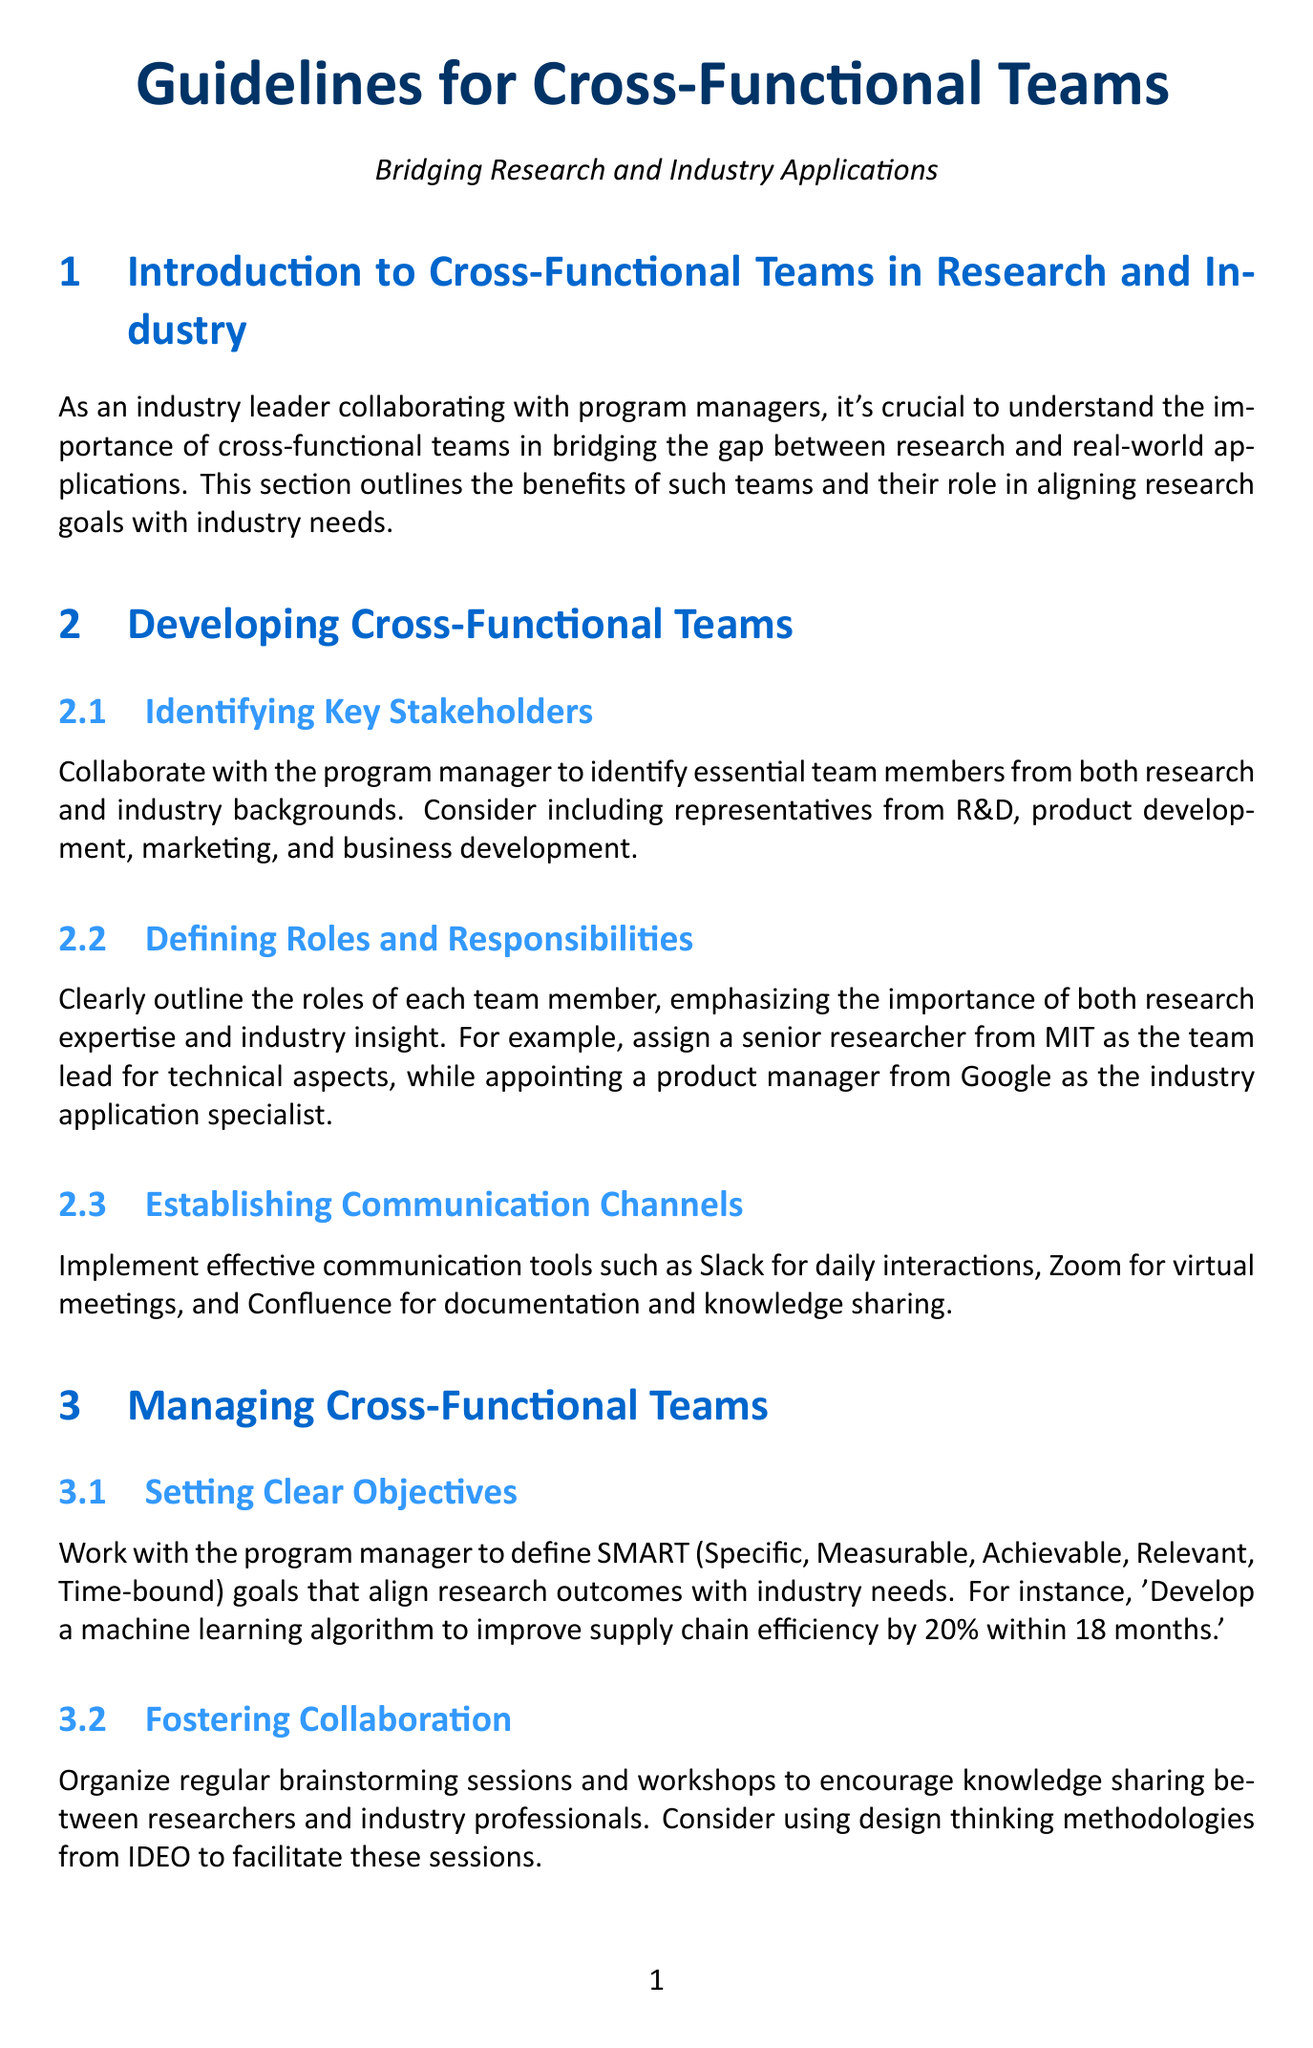What is the primary focus of cross-functional teams? The primary focus is to bridge the gap between research and real-world applications.
Answer: bridging the gap between research and real-world applications Who should be included as key stakeholders? Key stakeholders include representatives from R&D, product development, marketing, and business development.
Answer: R&D, product development, marketing, and business development What methodology can be used to foster collaboration? Design thinking methodologies from IDEO can be used to facilitate collaboration sessions.
Answer: design thinking methodologies from IDEO How many patents filed is a metric for research impact? The document suggests tracking the number of patents filed as a metric for research impact, but does not specify a number.
Answer: number of patents filed What is the purpose of the Team Effectiveness Questionnaire? The purpose of the Team Effectiveness Questionnaire is to assess team satisfaction.
Answer: assess team satisfaction What instrument is recommended for conflict resolution? The Thomas-Kilmann Conflict Mode Instrument is recommended for conflict resolution techniques.
Answer: Thomas-Kilmann Conflict Mode Instrument What does SMART stand for? SMART goals stand for Specific, Measurable, Achievable, Relevant, Time-bound.
Answer: Specific, Measurable, Achievable, Relevant, Time-bound Which company's collaboration is highlighted as a success story? The success story highlighted is the collaboration between IBM and MIT.
Answer: IBM and MIT What does the document emphasize about research goals? The document emphasizes that research goals should not be compromised while pursuing practical applications.
Answer: not be compromised while pursuing practical applications 